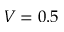<formula> <loc_0><loc_0><loc_500><loc_500>V = 0 . 5</formula> 